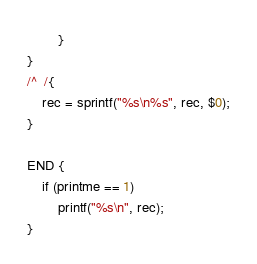Convert code to text. <code><loc_0><loc_0><loc_500><loc_500><_Awk_>		}
}
/^	/{
	rec = sprintf("%s\n%s", rec, $0);
}

END {
	if (printme == 1)
		printf("%s\n", rec);
}
</code> 